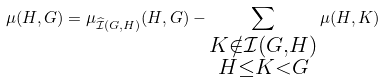Convert formula to latex. <formula><loc_0><loc_0><loc_500><loc_500>\mu ( H , G ) = \mu _ { \widehat { \mathcal { I } } ( G , H ) } ( H , G ) - \sum _ { \substack { K \notin \mathcal { I } ( G , H ) \\ H \leq K < G } } \mu ( H , K ) \,</formula> 